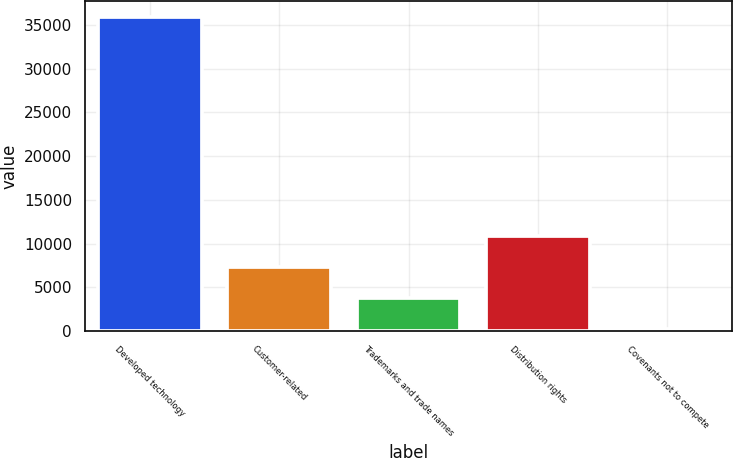<chart> <loc_0><loc_0><loc_500><loc_500><bar_chart><fcel>Developed technology<fcel>Customer-related<fcel>Trademarks and trade names<fcel>Distribution rights<fcel>Covenants not to compete<nl><fcel>35920<fcel>7344<fcel>3772<fcel>10916<fcel>200<nl></chart> 